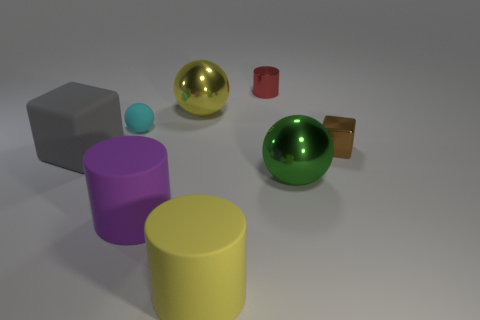What is the color of the large cylinder on the left side of the yellow thing in front of the large metallic object that is behind the tiny brown shiny block?
Make the answer very short. Purple. How many purple objects are tiny matte things or large cylinders?
Your answer should be compact. 1. What number of other objects are the same size as the purple rubber thing?
Give a very brief answer. 4. What number of objects are there?
Your response must be concise. 8. Are there any other things that are the same shape as the gray thing?
Offer a terse response. Yes. Does the yellow object in front of the large gray cube have the same material as the large yellow thing behind the big yellow rubber cylinder?
Ensure brevity in your answer.  No. What is the yellow sphere made of?
Your answer should be very brief. Metal. What number of blocks are made of the same material as the cyan thing?
Give a very brief answer. 1. How many matte things are either tiny blocks or large blue things?
Provide a succinct answer. 0. Is the shape of the large rubber object on the left side of the purple cylinder the same as the small object in front of the small cyan sphere?
Your answer should be compact. Yes. 